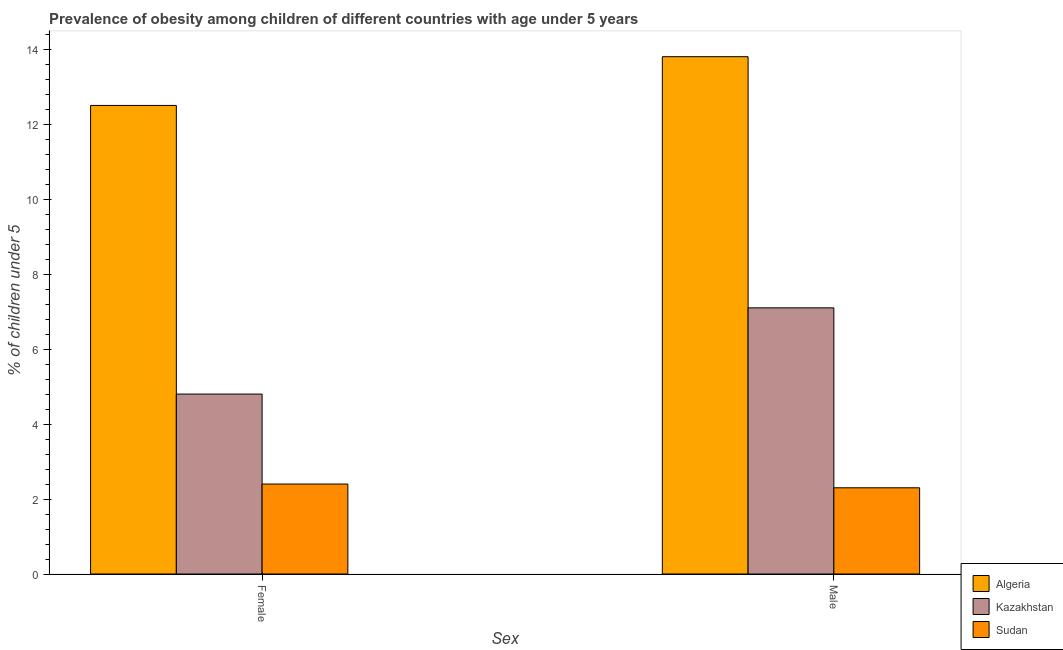How many different coloured bars are there?
Ensure brevity in your answer.  3. How many bars are there on the 1st tick from the right?
Provide a succinct answer. 3. What is the label of the 2nd group of bars from the left?
Give a very brief answer. Male. What is the percentage of obese male children in Sudan?
Ensure brevity in your answer.  2.3. Across all countries, what is the maximum percentage of obese male children?
Offer a terse response. 13.8. Across all countries, what is the minimum percentage of obese male children?
Give a very brief answer. 2.3. In which country was the percentage of obese male children maximum?
Your answer should be compact. Algeria. In which country was the percentage of obese female children minimum?
Keep it short and to the point. Sudan. What is the total percentage of obese female children in the graph?
Make the answer very short. 19.7. What is the difference between the percentage of obese male children in Kazakhstan and that in Algeria?
Your answer should be very brief. -6.7. What is the difference between the percentage of obese female children in Kazakhstan and the percentage of obese male children in Algeria?
Your answer should be very brief. -9. What is the average percentage of obese male children per country?
Keep it short and to the point. 7.73. What is the difference between the percentage of obese female children and percentage of obese male children in Algeria?
Keep it short and to the point. -1.3. In how many countries, is the percentage of obese female children greater than 7.6 %?
Make the answer very short. 1. What is the ratio of the percentage of obese female children in Sudan to that in Algeria?
Ensure brevity in your answer.  0.19. In how many countries, is the percentage of obese male children greater than the average percentage of obese male children taken over all countries?
Your response must be concise. 1. What does the 3rd bar from the left in Male represents?
Give a very brief answer. Sudan. What does the 2nd bar from the right in Male represents?
Your answer should be very brief. Kazakhstan. How many bars are there?
Your answer should be compact. 6. How many countries are there in the graph?
Offer a very short reply. 3. Does the graph contain any zero values?
Provide a succinct answer. No. Does the graph contain grids?
Offer a terse response. No. Where does the legend appear in the graph?
Your response must be concise. Bottom right. How many legend labels are there?
Offer a terse response. 3. How are the legend labels stacked?
Provide a short and direct response. Vertical. What is the title of the graph?
Offer a very short reply. Prevalence of obesity among children of different countries with age under 5 years. What is the label or title of the X-axis?
Keep it short and to the point. Sex. What is the label or title of the Y-axis?
Your response must be concise.  % of children under 5. What is the  % of children under 5 in Algeria in Female?
Offer a very short reply. 12.5. What is the  % of children under 5 in Kazakhstan in Female?
Make the answer very short. 4.8. What is the  % of children under 5 in Sudan in Female?
Your answer should be compact. 2.4. What is the  % of children under 5 of Algeria in Male?
Your response must be concise. 13.8. What is the  % of children under 5 in Kazakhstan in Male?
Provide a succinct answer. 7.1. What is the  % of children under 5 in Sudan in Male?
Your response must be concise. 2.3. Across all Sex, what is the maximum  % of children under 5 in Algeria?
Ensure brevity in your answer.  13.8. Across all Sex, what is the maximum  % of children under 5 in Kazakhstan?
Keep it short and to the point. 7.1. Across all Sex, what is the maximum  % of children under 5 of Sudan?
Provide a succinct answer. 2.4. Across all Sex, what is the minimum  % of children under 5 of Algeria?
Ensure brevity in your answer.  12.5. Across all Sex, what is the minimum  % of children under 5 of Kazakhstan?
Offer a terse response. 4.8. Across all Sex, what is the minimum  % of children under 5 in Sudan?
Ensure brevity in your answer.  2.3. What is the total  % of children under 5 in Algeria in the graph?
Keep it short and to the point. 26.3. What is the total  % of children under 5 of Sudan in the graph?
Ensure brevity in your answer.  4.7. What is the difference between the  % of children under 5 in Sudan in Female and that in Male?
Your response must be concise. 0.1. What is the difference between the  % of children under 5 in Algeria in Female and the  % of children under 5 in Kazakhstan in Male?
Give a very brief answer. 5.4. What is the difference between the  % of children under 5 in Algeria in Female and the  % of children under 5 in Sudan in Male?
Provide a succinct answer. 10.2. What is the difference between the  % of children under 5 in Kazakhstan in Female and the  % of children under 5 in Sudan in Male?
Give a very brief answer. 2.5. What is the average  % of children under 5 of Algeria per Sex?
Offer a terse response. 13.15. What is the average  % of children under 5 in Kazakhstan per Sex?
Your answer should be compact. 5.95. What is the average  % of children under 5 in Sudan per Sex?
Offer a very short reply. 2.35. What is the difference between the  % of children under 5 of Algeria and  % of children under 5 of Sudan in Female?
Ensure brevity in your answer.  10.1. What is the difference between the  % of children under 5 of Algeria and  % of children under 5 of Sudan in Male?
Keep it short and to the point. 11.5. What is the difference between the  % of children under 5 in Kazakhstan and  % of children under 5 in Sudan in Male?
Your response must be concise. 4.8. What is the ratio of the  % of children under 5 in Algeria in Female to that in Male?
Offer a terse response. 0.91. What is the ratio of the  % of children under 5 of Kazakhstan in Female to that in Male?
Keep it short and to the point. 0.68. What is the ratio of the  % of children under 5 of Sudan in Female to that in Male?
Your response must be concise. 1.04. What is the difference between the highest and the second highest  % of children under 5 in Algeria?
Provide a short and direct response. 1.3. What is the difference between the highest and the second highest  % of children under 5 of Sudan?
Your answer should be very brief. 0.1. What is the difference between the highest and the lowest  % of children under 5 in Algeria?
Offer a very short reply. 1.3. What is the difference between the highest and the lowest  % of children under 5 of Kazakhstan?
Provide a succinct answer. 2.3. 